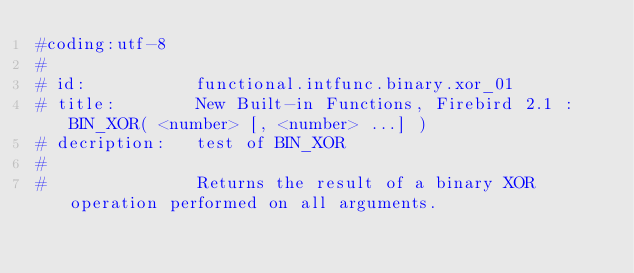Convert code to text. <code><loc_0><loc_0><loc_500><loc_500><_Python_>#coding:utf-8
#
# id:           functional.intfunc.binary.xor_01
# title:        New Built-in Functions, Firebird 2.1 : BIN_XOR( <number> [, <number> ...] )
# decription:   test of BIN_XOR
#               
#               Returns the result of a binary XOR operation performed on all arguments.</code> 